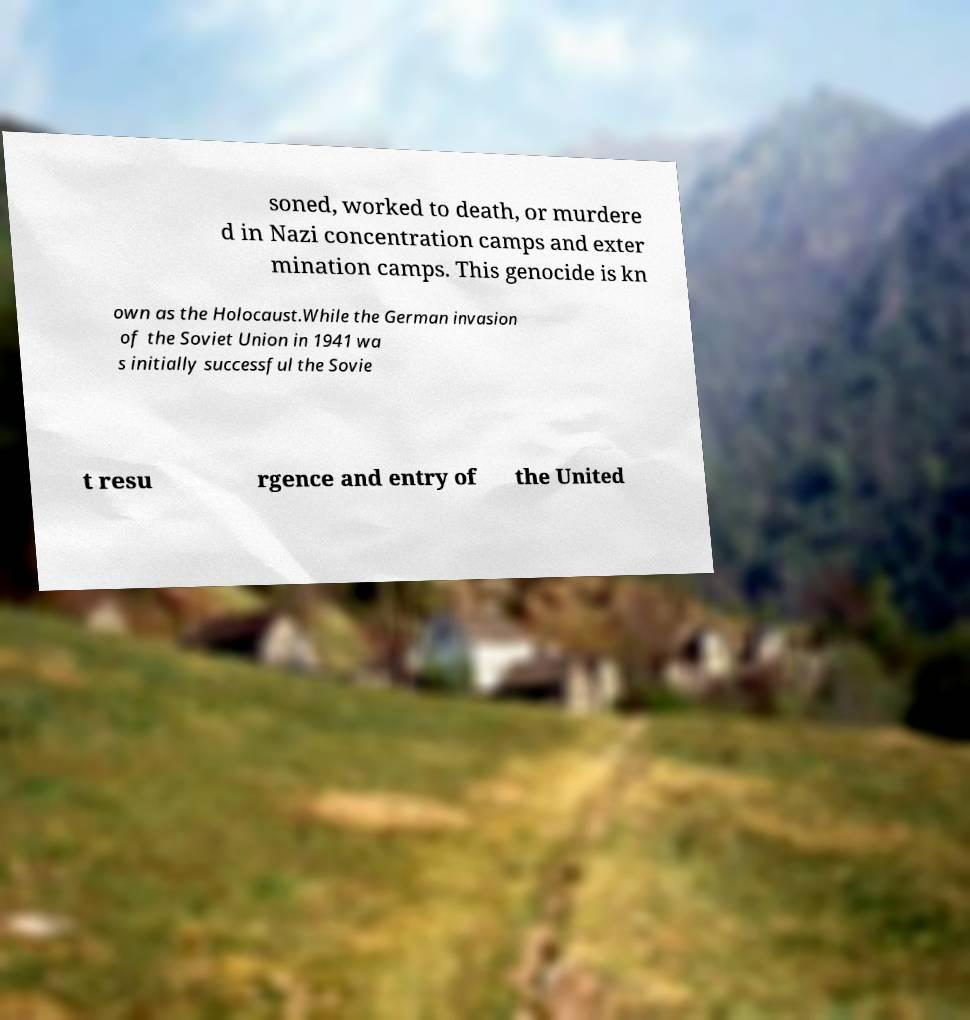Can you read and provide the text displayed in the image?This photo seems to have some interesting text. Can you extract and type it out for me? soned, worked to death, or murdere d in Nazi concentration camps and exter mination camps. This genocide is kn own as the Holocaust.While the German invasion of the Soviet Union in 1941 wa s initially successful the Sovie t resu rgence and entry of the United 